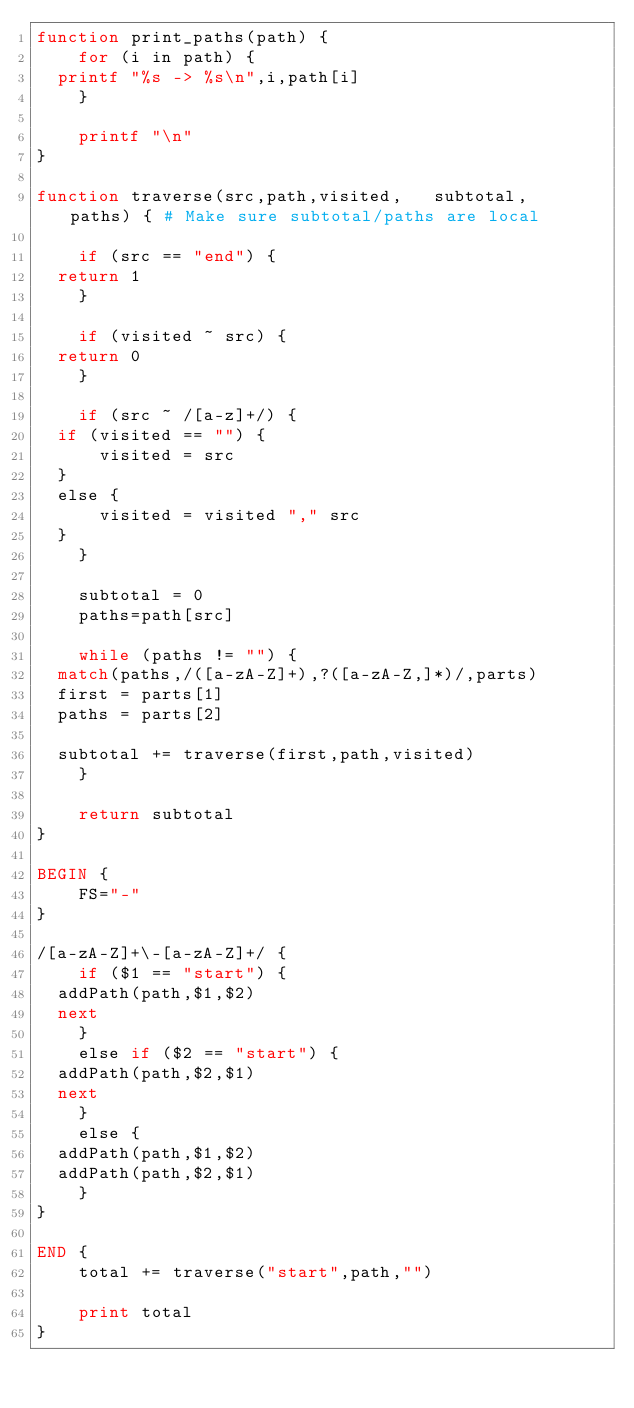<code> <loc_0><loc_0><loc_500><loc_500><_Awk_>function print_paths(path) {
    for (i in path) {
	printf "%s -> %s\n",i,path[i]
    }

    printf "\n"
}

function traverse(src,path,visited,   subtotal,   paths) { # Make sure subtotal/paths are local

    if (src == "end") {
	return 1
    }

    if (visited ~ src) {
	return 0
    }

    if (src ~ /[a-z]+/) {
	if (visited == "") {
	    visited = src
	}
	else {
	    visited = visited "," src
	}
    }

    subtotal = 0
    paths=path[src]

    while (paths != "") {
	match(paths,/([a-zA-Z]+),?([a-zA-Z,]*)/,parts)
	first = parts[1]
	paths = parts[2]

	subtotal += traverse(first,path,visited)
    }

    return subtotal
}

BEGIN {
    FS="-"
}

/[a-zA-Z]+\-[a-zA-Z]+/ {
    if ($1 == "start") {
	addPath(path,$1,$2)
	next
    }
    else if ($2 == "start") {
	addPath(path,$2,$1)
	next
    }
    else {
	addPath(path,$1,$2)
	addPath(path,$2,$1)
    }
}

END {
    total += traverse("start",path,"")

    print total
}
</code> 